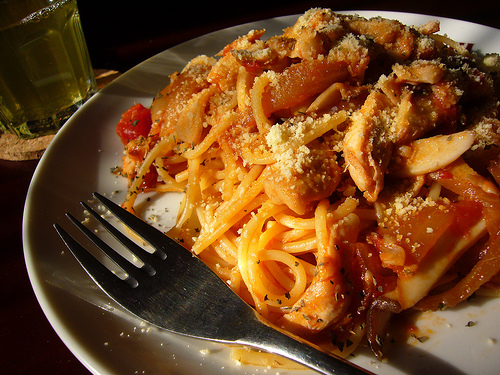<image>
Is the fork in front of the plate? No. The fork is not in front of the plate. The spatial positioning shows a different relationship between these objects. 